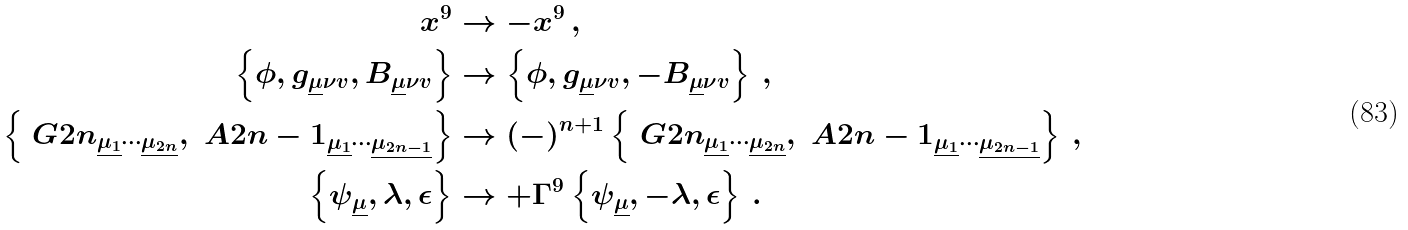<formula> <loc_0><loc_0><loc_500><loc_500>x ^ { 9 } & \rightarrow - x ^ { 9 } \, , \\ \left \{ \phi , g _ { \underline { \mu } \nu v } , B _ { \underline { \mu } \nu v } \right \} & \rightarrow \left \{ \phi , g _ { \underline { \mu } \nu v } , - B _ { \underline { \mu } \nu v } \right \} \, , \\ \left \{ \ G { 2 n } _ { \underline { \mu _ { 1 } } \cdots \underline { \mu _ { 2 n } } } , \ A { 2 n - 1 } _ { \underline { \mu _ { 1 } } \cdots \underline { \mu _ { 2 n - 1 } } } \right \} & \rightarrow ( - ) ^ { n + 1 } \left \{ \ G { 2 n } _ { \underline { \mu _ { 1 } } \cdots \underline { \mu _ { 2 n } } } , \ A { 2 n - 1 } _ { \underline { \mu _ { 1 } } \cdots \underline { \mu _ { 2 n - 1 } } } \right \} \, , \\ \left \{ \psi _ { \underline { \mu } } , \lambda , \epsilon \right \} & \rightarrow + \Gamma ^ { 9 } \left \{ \psi _ { \underline { \mu } } , - \lambda , \epsilon \right \} \, .</formula> 